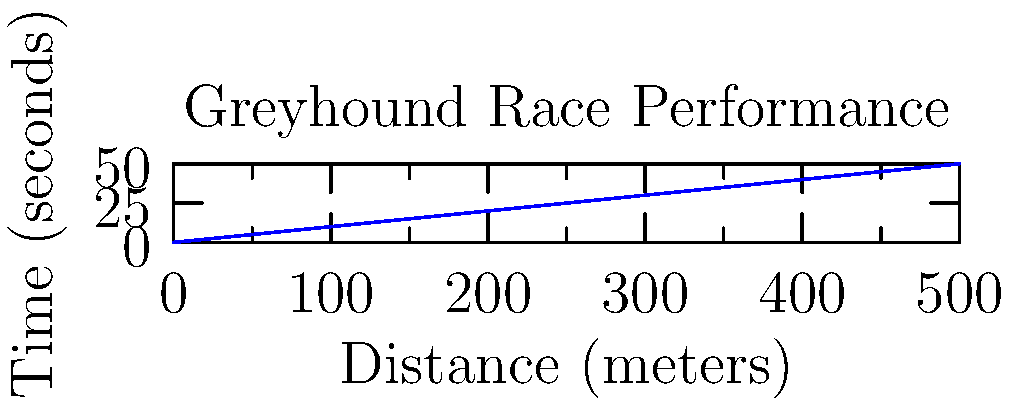In a thrilling greyhound race, you've managed to capture the dog's progress using a stopwatch. The graph shows the distance covered by the greyhound over time. What was the average speed of the greyhound throughout the entire race? To calculate the average speed of the greyhound, we need to follow these steps:

1. Identify the total distance covered:
   From the graph, we can see that the race distance is 500 meters.

2. Identify the total time taken:
   The graph shows that it took 50 seconds to complete the race.

3. Use the formula for average speed:
   Average Speed = Total Distance / Total Time

4. Plug in the values:
   Average Speed = 500 meters / 50 seconds

5. Perform the calculation:
   Average Speed = 10 meters/second

6. Convert to a more common unit for racing speeds (optional):
   10 m/s = 10 * 3.6 km/h = 36 km/h

Therefore, the average speed of the greyhound throughout the entire race was 10 meters per second or 36 kilometers per hour.
Answer: 10 m/s (or 36 km/h) 